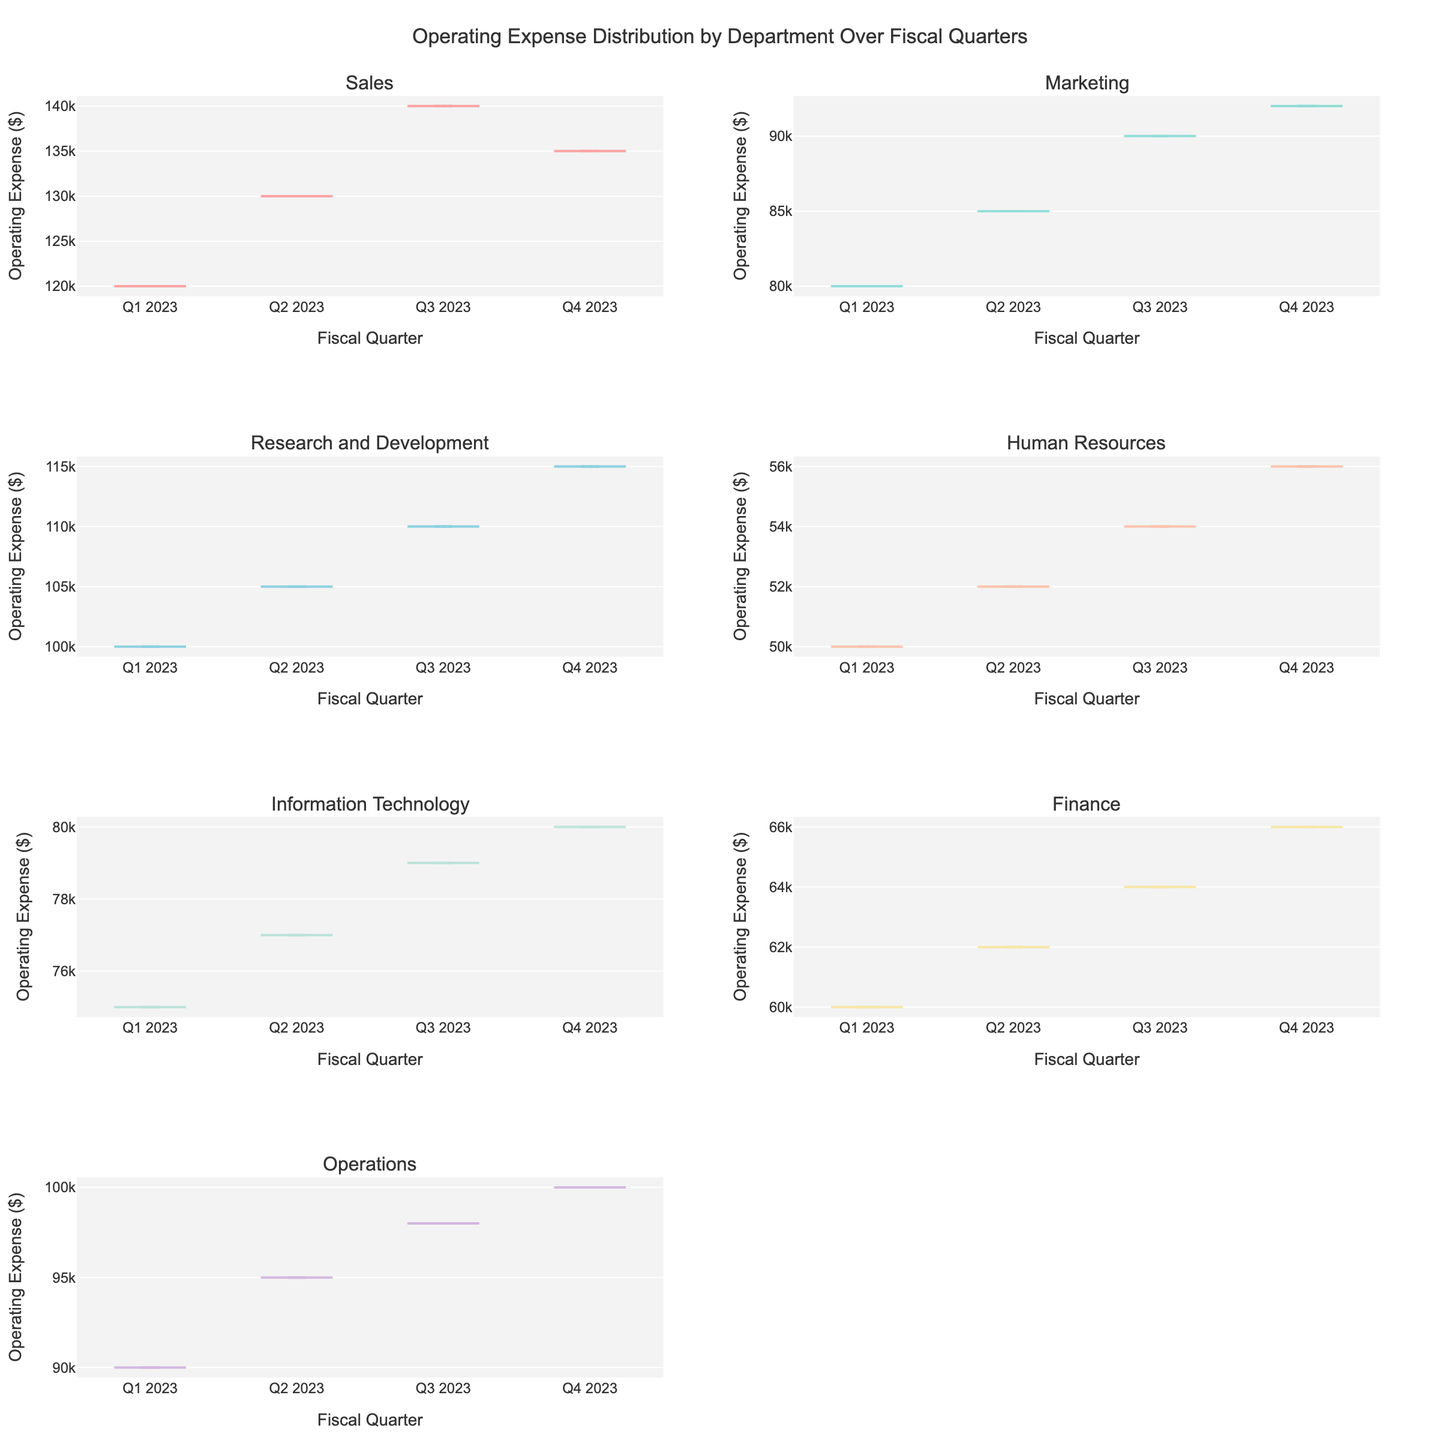What is the title of the figure? The title is located at the top of the figure, clearly stating its purpose.
Answer: Operating Expense Distribution by Department Over Fiscal Quarters Which department has the highest operating expense in Q3 2023? Look at the subplot for each department and identify the highest operating expense value for Q3 2023.
Answer: Sales How does the median operating expense for the Sales department in Q2 2023 compare to Q1 2023? Locate the violin plot for Sales and compare the median lines for Q2 2023 and Q1 2023. The median is represented by a line within the box.
Answer: Higher in Q2 2023 Which department shows the lowest operating expense in Q1 2023? Check each subplot for Q1 2023 and identify the department with the lowest expense value.
Answer: Human Resources Are the operating expenses more spread out for the IT department or the Operations department in Q4 2023? Examine the violin plots for both IT and Operations departments in Q4 2023. The spread is indicated by the width of the violin plots.
Answer: Operations What is the range of operating expenses for the Marketing department in Q3 2023? Look at the Marketing department's subplot for Q3 2023 and identify the maximum and minimum operating expenses to calculate the range.
Answer: 90,000 - 80,000 Does any department show a significant increase in operating expenses from Q1 2023 to Q4 2023? Compare the operating expenses for all departments from Q1 2023 to Q4 2023 to determine if there is a significant increase.
Answer: Research and Development Which department has the least variation in operating expenses across all fiscal quarters? Look at the spread of operating expenses in each department’s violin plots. The department with the narrowest plots has the least variation.
Answer: Finance How do the mean operating expenses for the Finance and Marketing departments in Q2 2023 compare? Compare the mean lines (indicated in the violin plots) for Finance and Marketing departments in Q2 2023.
Answer: Marketing has higher mean Is there a department that had consistent operating expenses close to their median value across all quarters? Identify the department(s) with narrow violin plots and mean lines close to the median across all quarters for consistency.
Answer: Human Resources 